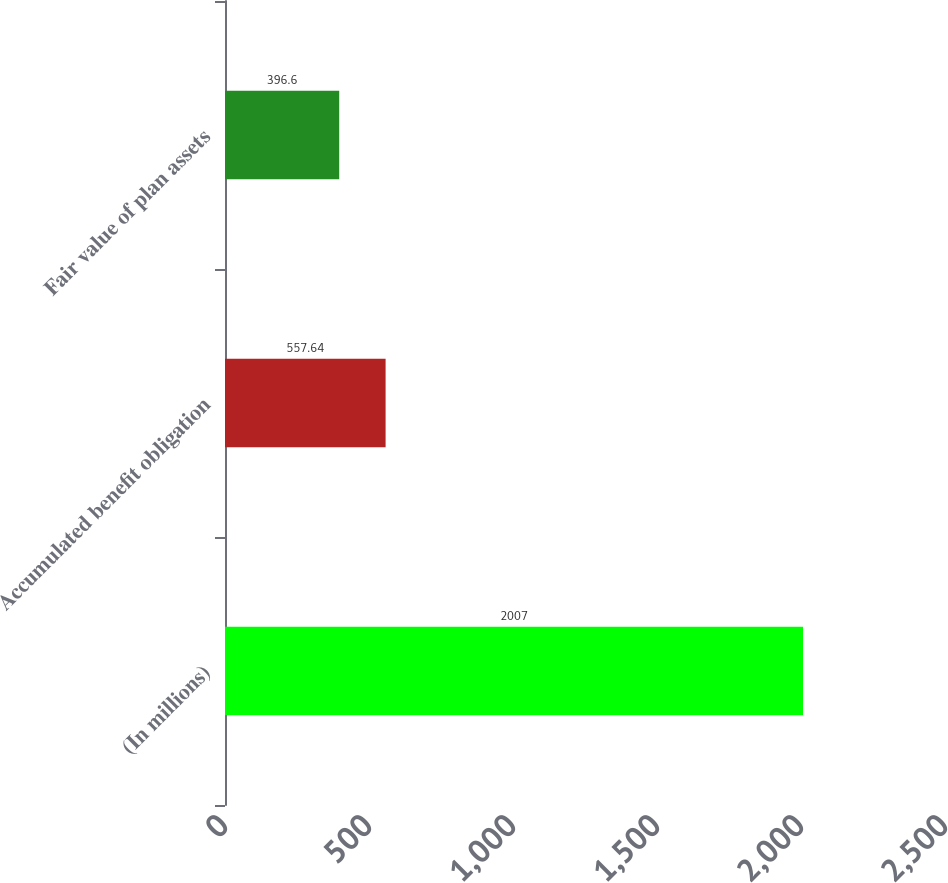<chart> <loc_0><loc_0><loc_500><loc_500><bar_chart><fcel>(In millions)<fcel>Accumulated benefit obligation<fcel>Fair value of plan assets<nl><fcel>2007<fcel>557.64<fcel>396.6<nl></chart> 